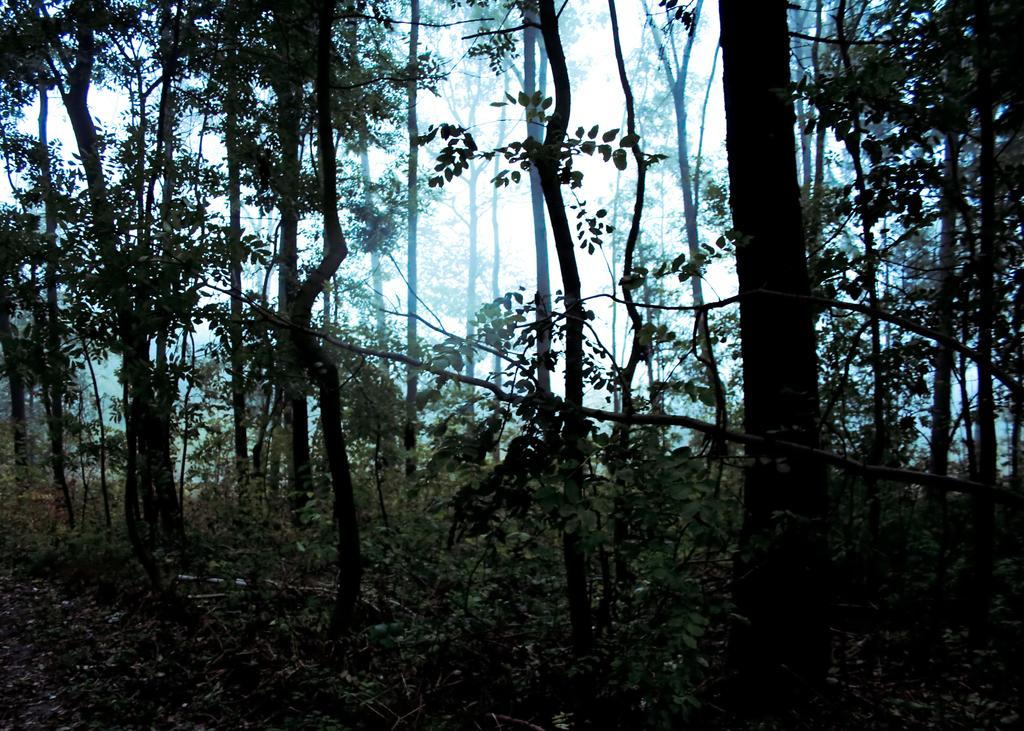What type of vegetation can be seen in the image? There are green color trees in the image. What part of the natural environment is visible in the image? The sky is visible in the image. Can you see a worm crawling on the trees in the image? There is no worm present in the image; it only features green color trees and the sky. 